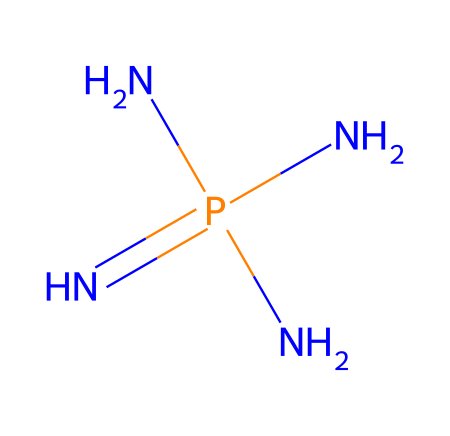What is the central atom in this chemical? The central atom can be identified by examining the structure; the phosphorus atom (P) is bonded to nitrogen atoms and is the central component of the phosphazene base.
Answer: phosphorus How many nitrogen atoms are present in this chemical? By analyzing the SMILES representation, we see three nitrogen atoms (N) surrounding the central phosphorus atom (P).
Answer: three Does this compound exhibit basic or acidic properties? The presence of multiple nitrogen atoms suggests that this compound is a strong base, known for its ability to donate electron pairs.
Answer: basic What is the general category of compounds that this chemical belongs to? This chemical belongs to the category of phosphazenes, which are characterized by a phosphorus-nitrogen backbone and often exhibit unique chemical properties.
Answer: phosphazenes How many valence electrons are contributed by nitrogen in this molecule? Each nitrogen atom contributes five valence electrons, and since there are three nitrogen atoms, they collectively contribute a total of 15 valence electrons.
Answer: fifteen What type of reaction might this compound catalyze in alternative medicine research? Given its strong basicity and unique structure, phosphazene bases like this one might serve as catalysts in reactions for synthesizing biologically active compounds, reflecting their potential in alternative medicine.
Answer: synthesis 